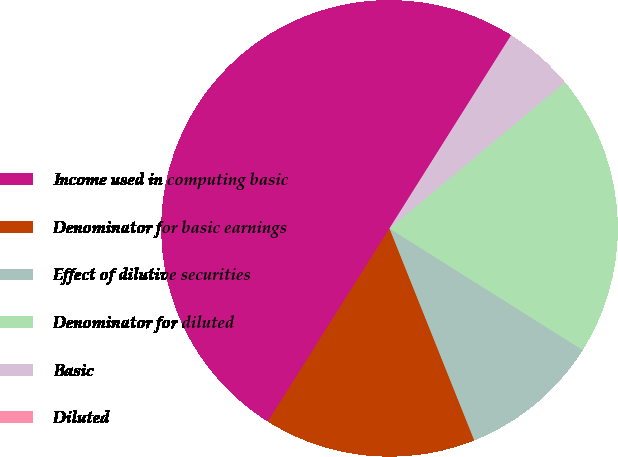<chart> <loc_0><loc_0><loc_500><loc_500><pie_chart><fcel>Income used in computing basic<fcel>Denominator for basic earnings<fcel>Effect of dilutive securities<fcel>Denominator for diluted<fcel>Basic<fcel>Diluted<nl><fcel>50.0%<fcel>15.0%<fcel>10.0%<fcel>20.0%<fcel>5.0%<fcel>0.0%<nl></chart> 